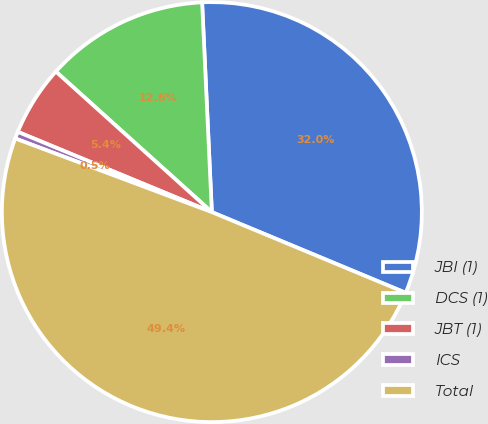Convert chart. <chart><loc_0><loc_0><loc_500><loc_500><pie_chart><fcel>JBI (1)<fcel>DCS (1)<fcel>JBT (1)<fcel>ICS<fcel>Total<nl><fcel>32.02%<fcel>12.59%<fcel>5.43%<fcel>0.54%<fcel>49.43%<nl></chart> 